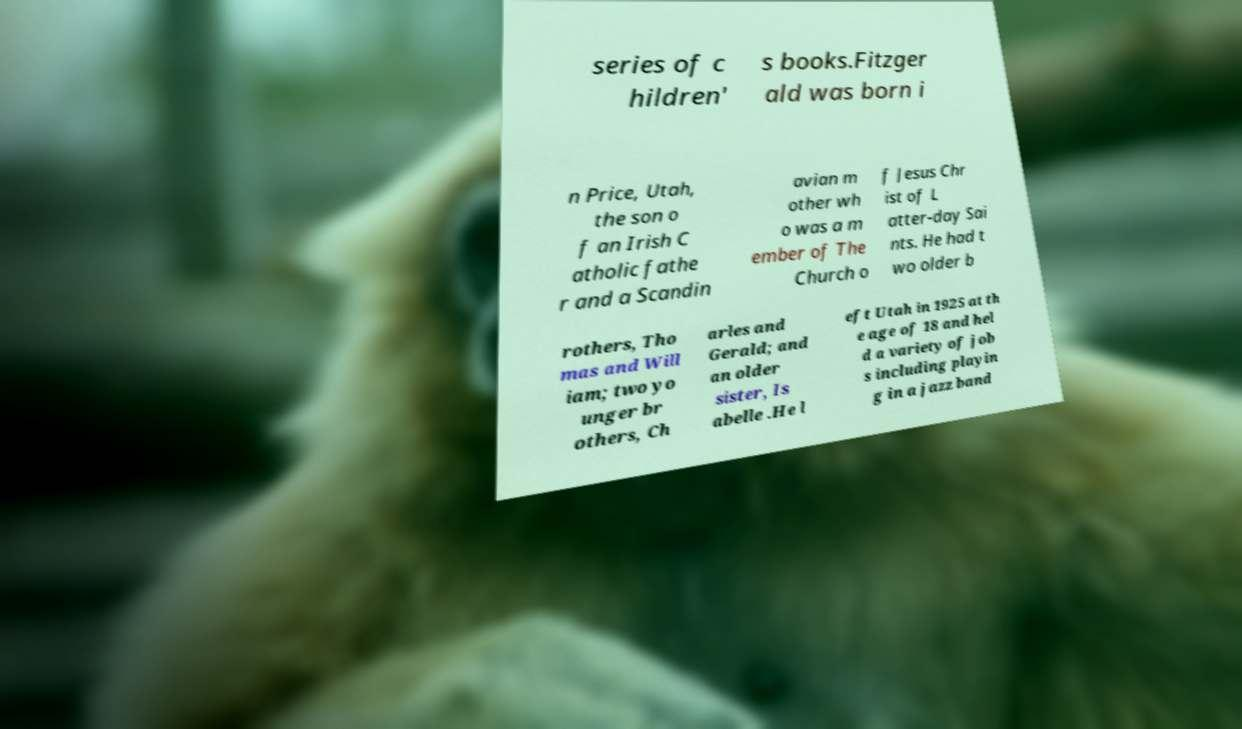Please identify and transcribe the text found in this image. series of c hildren' s books.Fitzger ald was born i n Price, Utah, the son o f an Irish C atholic fathe r and a Scandin avian m other wh o was a m ember of The Church o f Jesus Chr ist of L atter-day Sai nts. He had t wo older b rothers, Tho mas and Will iam; two yo unger br others, Ch arles and Gerald; and an older sister, Is abelle .He l eft Utah in 1925 at th e age of 18 and hel d a variety of job s including playin g in a jazz band 